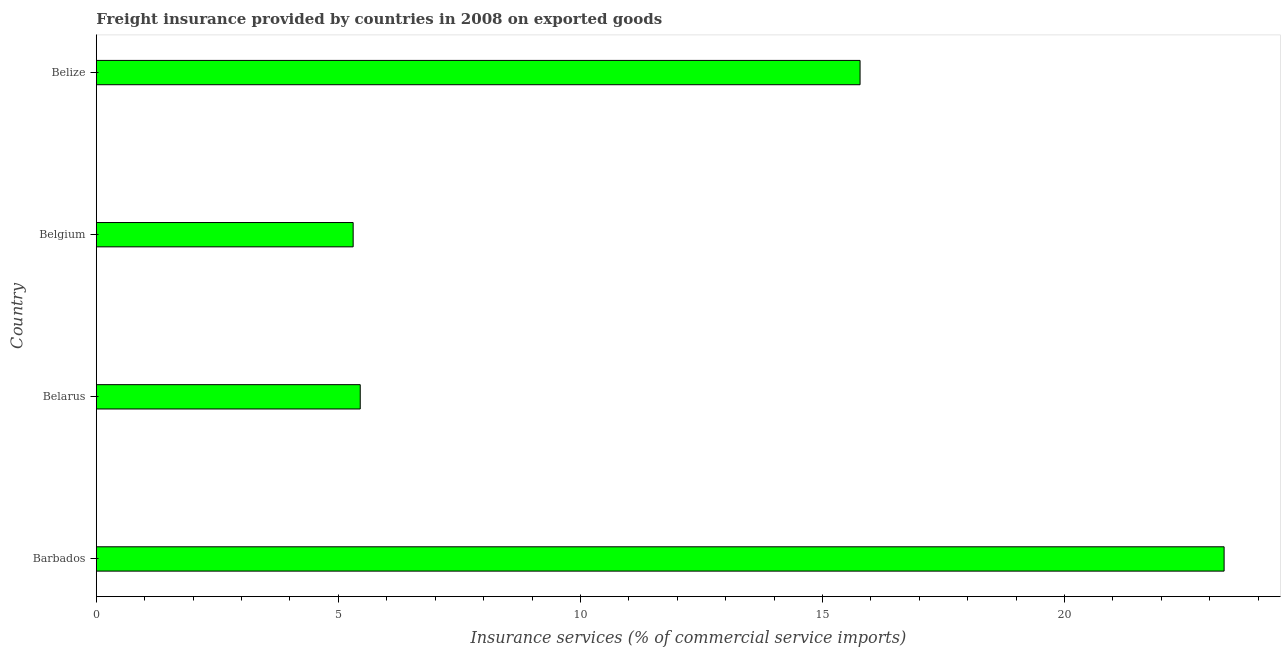Does the graph contain any zero values?
Give a very brief answer. No. What is the title of the graph?
Offer a terse response. Freight insurance provided by countries in 2008 on exported goods . What is the label or title of the X-axis?
Provide a short and direct response. Insurance services (% of commercial service imports). What is the freight insurance in Belarus?
Give a very brief answer. 5.45. Across all countries, what is the maximum freight insurance?
Keep it short and to the point. 23.3. Across all countries, what is the minimum freight insurance?
Your answer should be very brief. 5.31. In which country was the freight insurance maximum?
Provide a succinct answer. Barbados. In which country was the freight insurance minimum?
Your answer should be compact. Belgium. What is the sum of the freight insurance?
Give a very brief answer. 49.83. What is the difference between the freight insurance in Barbados and Belgium?
Give a very brief answer. 17.99. What is the average freight insurance per country?
Provide a succinct answer. 12.46. What is the median freight insurance?
Ensure brevity in your answer.  10.61. What is the ratio of the freight insurance in Belgium to that in Belize?
Offer a very short reply. 0.34. What is the difference between the highest and the second highest freight insurance?
Provide a succinct answer. 7.52. What is the difference between the highest and the lowest freight insurance?
Provide a short and direct response. 17.99. Are all the bars in the graph horizontal?
Make the answer very short. Yes. How many countries are there in the graph?
Make the answer very short. 4. Are the values on the major ticks of X-axis written in scientific E-notation?
Offer a very short reply. No. What is the Insurance services (% of commercial service imports) in Barbados?
Offer a very short reply. 23.3. What is the Insurance services (% of commercial service imports) in Belarus?
Give a very brief answer. 5.45. What is the Insurance services (% of commercial service imports) of Belgium?
Keep it short and to the point. 5.31. What is the Insurance services (% of commercial service imports) of Belize?
Provide a succinct answer. 15.78. What is the difference between the Insurance services (% of commercial service imports) in Barbados and Belarus?
Give a very brief answer. 17.85. What is the difference between the Insurance services (% of commercial service imports) in Barbados and Belgium?
Your response must be concise. 17.99. What is the difference between the Insurance services (% of commercial service imports) in Barbados and Belize?
Ensure brevity in your answer.  7.52. What is the difference between the Insurance services (% of commercial service imports) in Belarus and Belgium?
Offer a terse response. 0.15. What is the difference between the Insurance services (% of commercial service imports) in Belarus and Belize?
Your response must be concise. -10.33. What is the difference between the Insurance services (% of commercial service imports) in Belgium and Belize?
Your response must be concise. -10.47. What is the ratio of the Insurance services (% of commercial service imports) in Barbados to that in Belarus?
Keep it short and to the point. 4.27. What is the ratio of the Insurance services (% of commercial service imports) in Barbados to that in Belgium?
Your answer should be compact. 4.39. What is the ratio of the Insurance services (% of commercial service imports) in Barbados to that in Belize?
Ensure brevity in your answer.  1.48. What is the ratio of the Insurance services (% of commercial service imports) in Belarus to that in Belgium?
Your response must be concise. 1.03. What is the ratio of the Insurance services (% of commercial service imports) in Belarus to that in Belize?
Provide a succinct answer. 0.35. What is the ratio of the Insurance services (% of commercial service imports) in Belgium to that in Belize?
Your answer should be compact. 0.34. 